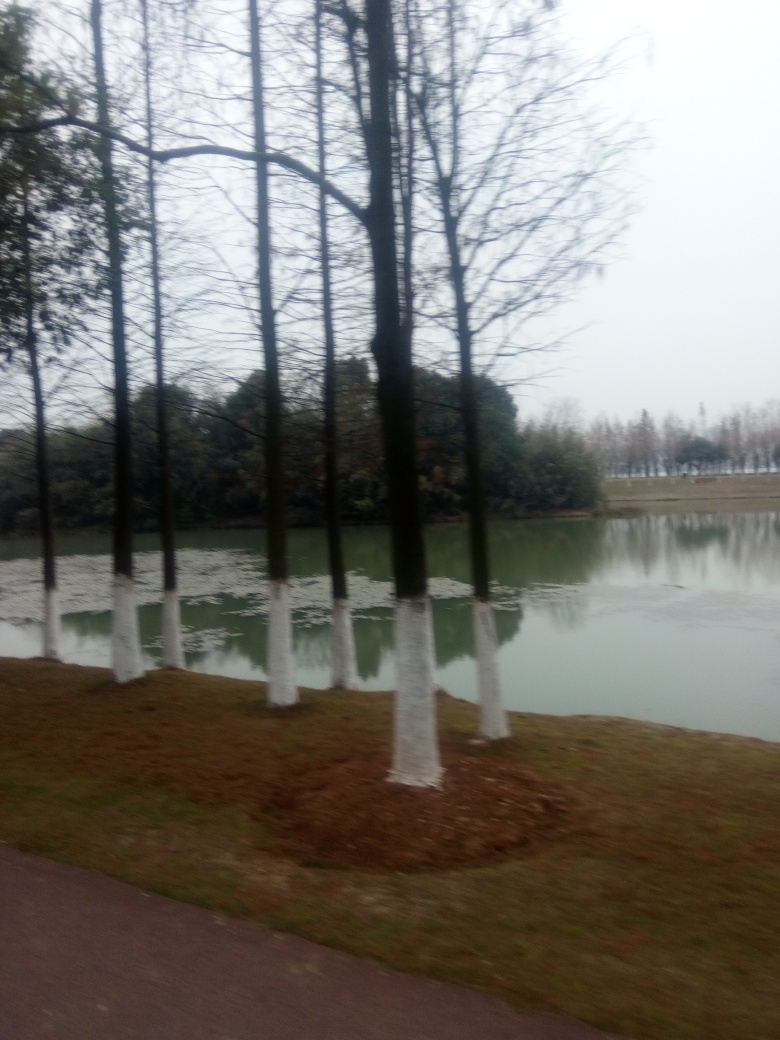Can the texture of the ground be clearly seen? Due to the blurred quality of the image, the texture of the ground is not clearly visible, though we can infer some grassy patches and possibly mulched areas around the trees. 